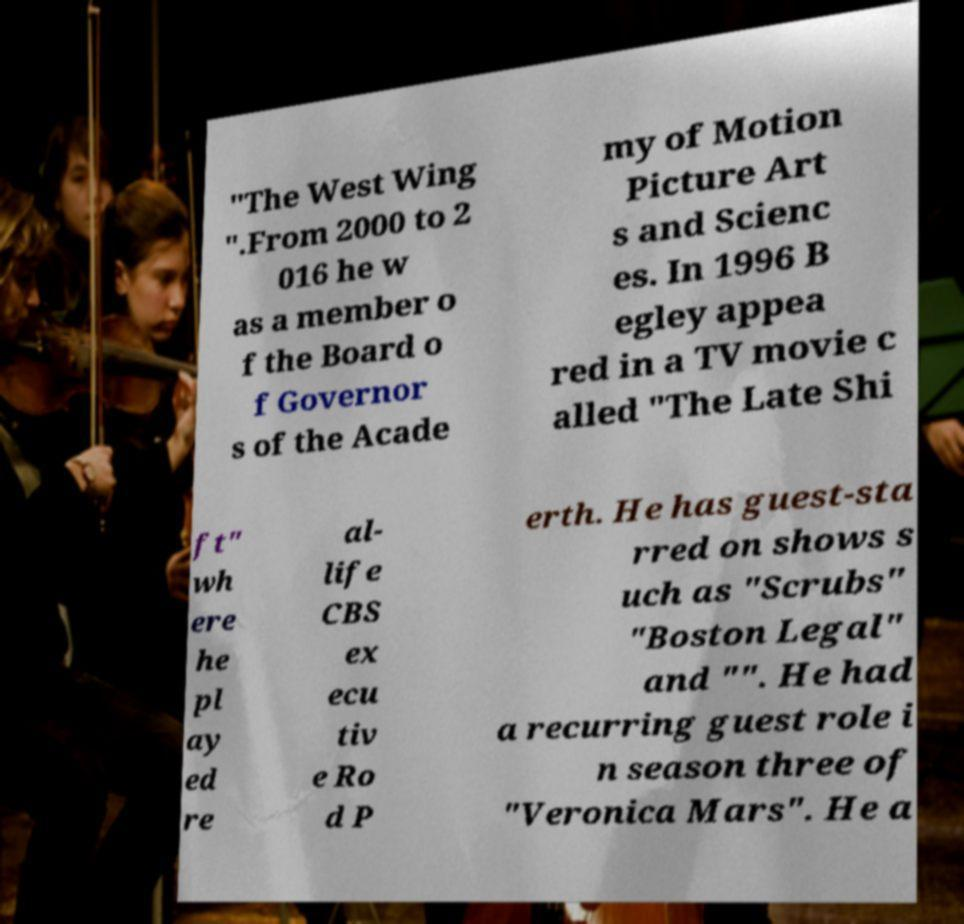Please read and relay the text visible in this image. What does it say? "The West Wing ".From 2000 to 2 016 he w as a member o f the Board o f Governor s of the Acade my of Motion Picture Art s and Scienc es. In 1996 B egley appea red in a TV movie c alled "The Late Shi ft" wh ere he pl ay ed re al- life CBS ex ecu tiv e Ro d P erth. He has guest-sta rred on shows s uch as "Scrubs" "Boston Legal" and "". He had a recurring guest role i n season three of "Veronica Mars". He a 